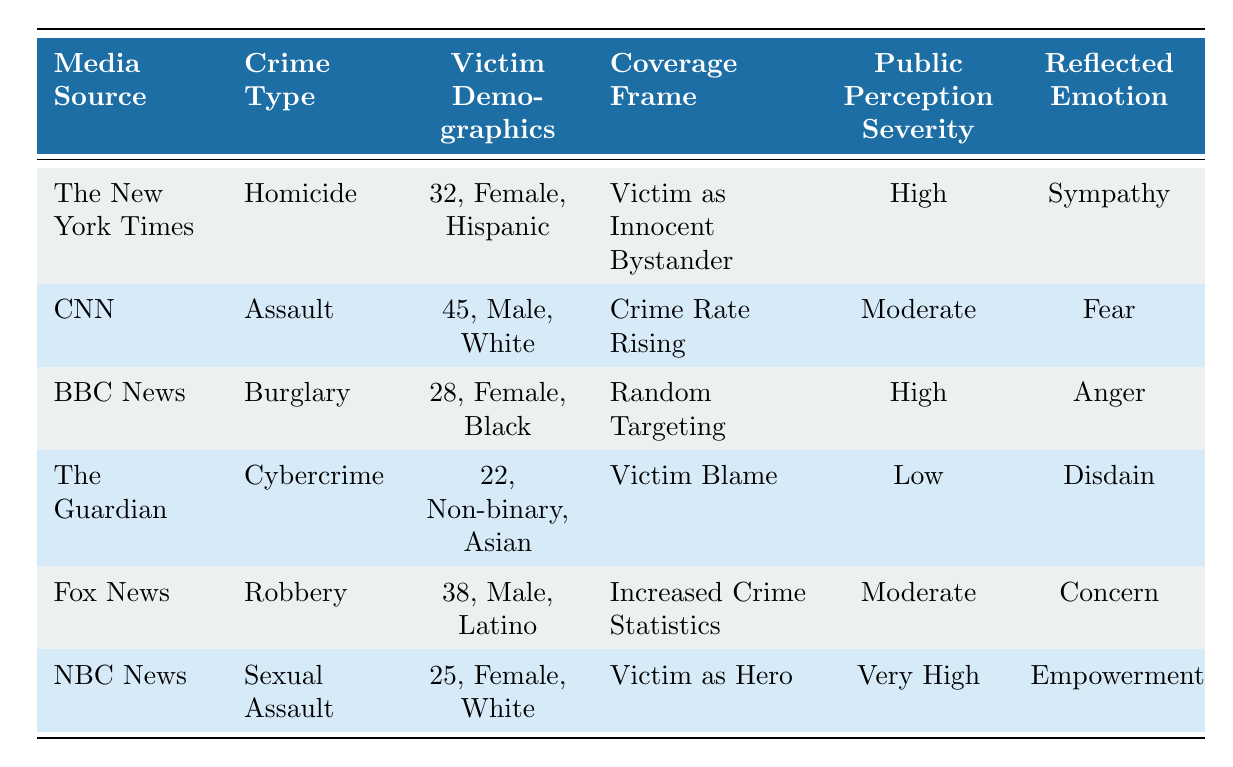What is the public perception severity of the homicide reported by The New York Times? The table shows that the homicide covered by The New York Times has a public perception severity of "High." This value can be found directly in the corresponding row for The New York Times and the crime type Homicide.
Answer: High How many different crime types are represented in the media coverage? Looking at the table, there are six unique crime types: Homicide, Assault, Burglary, Cybercrime, Robbery, and Sexual Assault. Each has its own row, and no crime type is repeated.
Answer: 6 What emotion is reflected in the media coverage of sexual assault? The table indicates that the reflected emotion for sexual assault in NBC News is "Empowerment." This can be determined by finding the corresponding row for Sexual Assault.
Answer: Empowerment Is there any crime type with very high public perception severity? Yes, according to the table, the crime type Sexual Assault has a public perception severity of "Very High," which is confirmed from the NBC News row.
Answer: Yes Which age group has the lowest public perception severity? The only crime type with low public perception severity is Cybercrime, which has a victim demographic of 22 years old associated with the coverage by The Guardian. By comparison with other entries, this is the lowest severity.
Answer: 22 years old What is the average age of victims for the crimes that have high public perception severity? The crimes with high public perception severity are Homicide (32), Burglary (28), and Sexual Assault (25). We calculate the average age as (32 + 28 + 25) / 3 = 28.33. Thus, the average age is approximately 28.33.
Answer: 28.33 What percentage of crime coverage reflected 'Fear' emotions? In the table, 'Fear' is reflected in the Assault covered by CNN. Since there are six total entries and only one reflects 'Fear,' the percentage is (1/6) * 100 = 16.67%.
Answer: 16.67% Which media source reported on a crime associated with a victim demographic of non-binary? The table shows that The Guardian reported on Cybercrime associated with a non-binary victim as indicated in its respective row.
Answer: The Guardian Was there any coverage that framed the victim as an innocent bystander? Yes, the table indicates that The New York Times framed the victim of homicide as an "Innocent Bystander." This fact is easily seen in the row for The New York Times and crime type Homicide.
Answer: Yes 